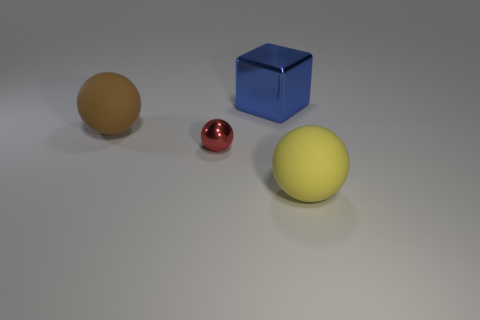Add 4 brown metal cylinders. How many objects exist? 8 Subtract all spheres. How many objects are left? 1 Subtract all blue metal balls. Subtract all red metal balls. How many objects are left? 3 Add 1 tiny red spheres. How many tiny red spheres are left? 2 Add 4 tiny metallic balls. How many tiny metallic balls exist? 5 Subtract 0 blue balls. How many objects are left? 4 